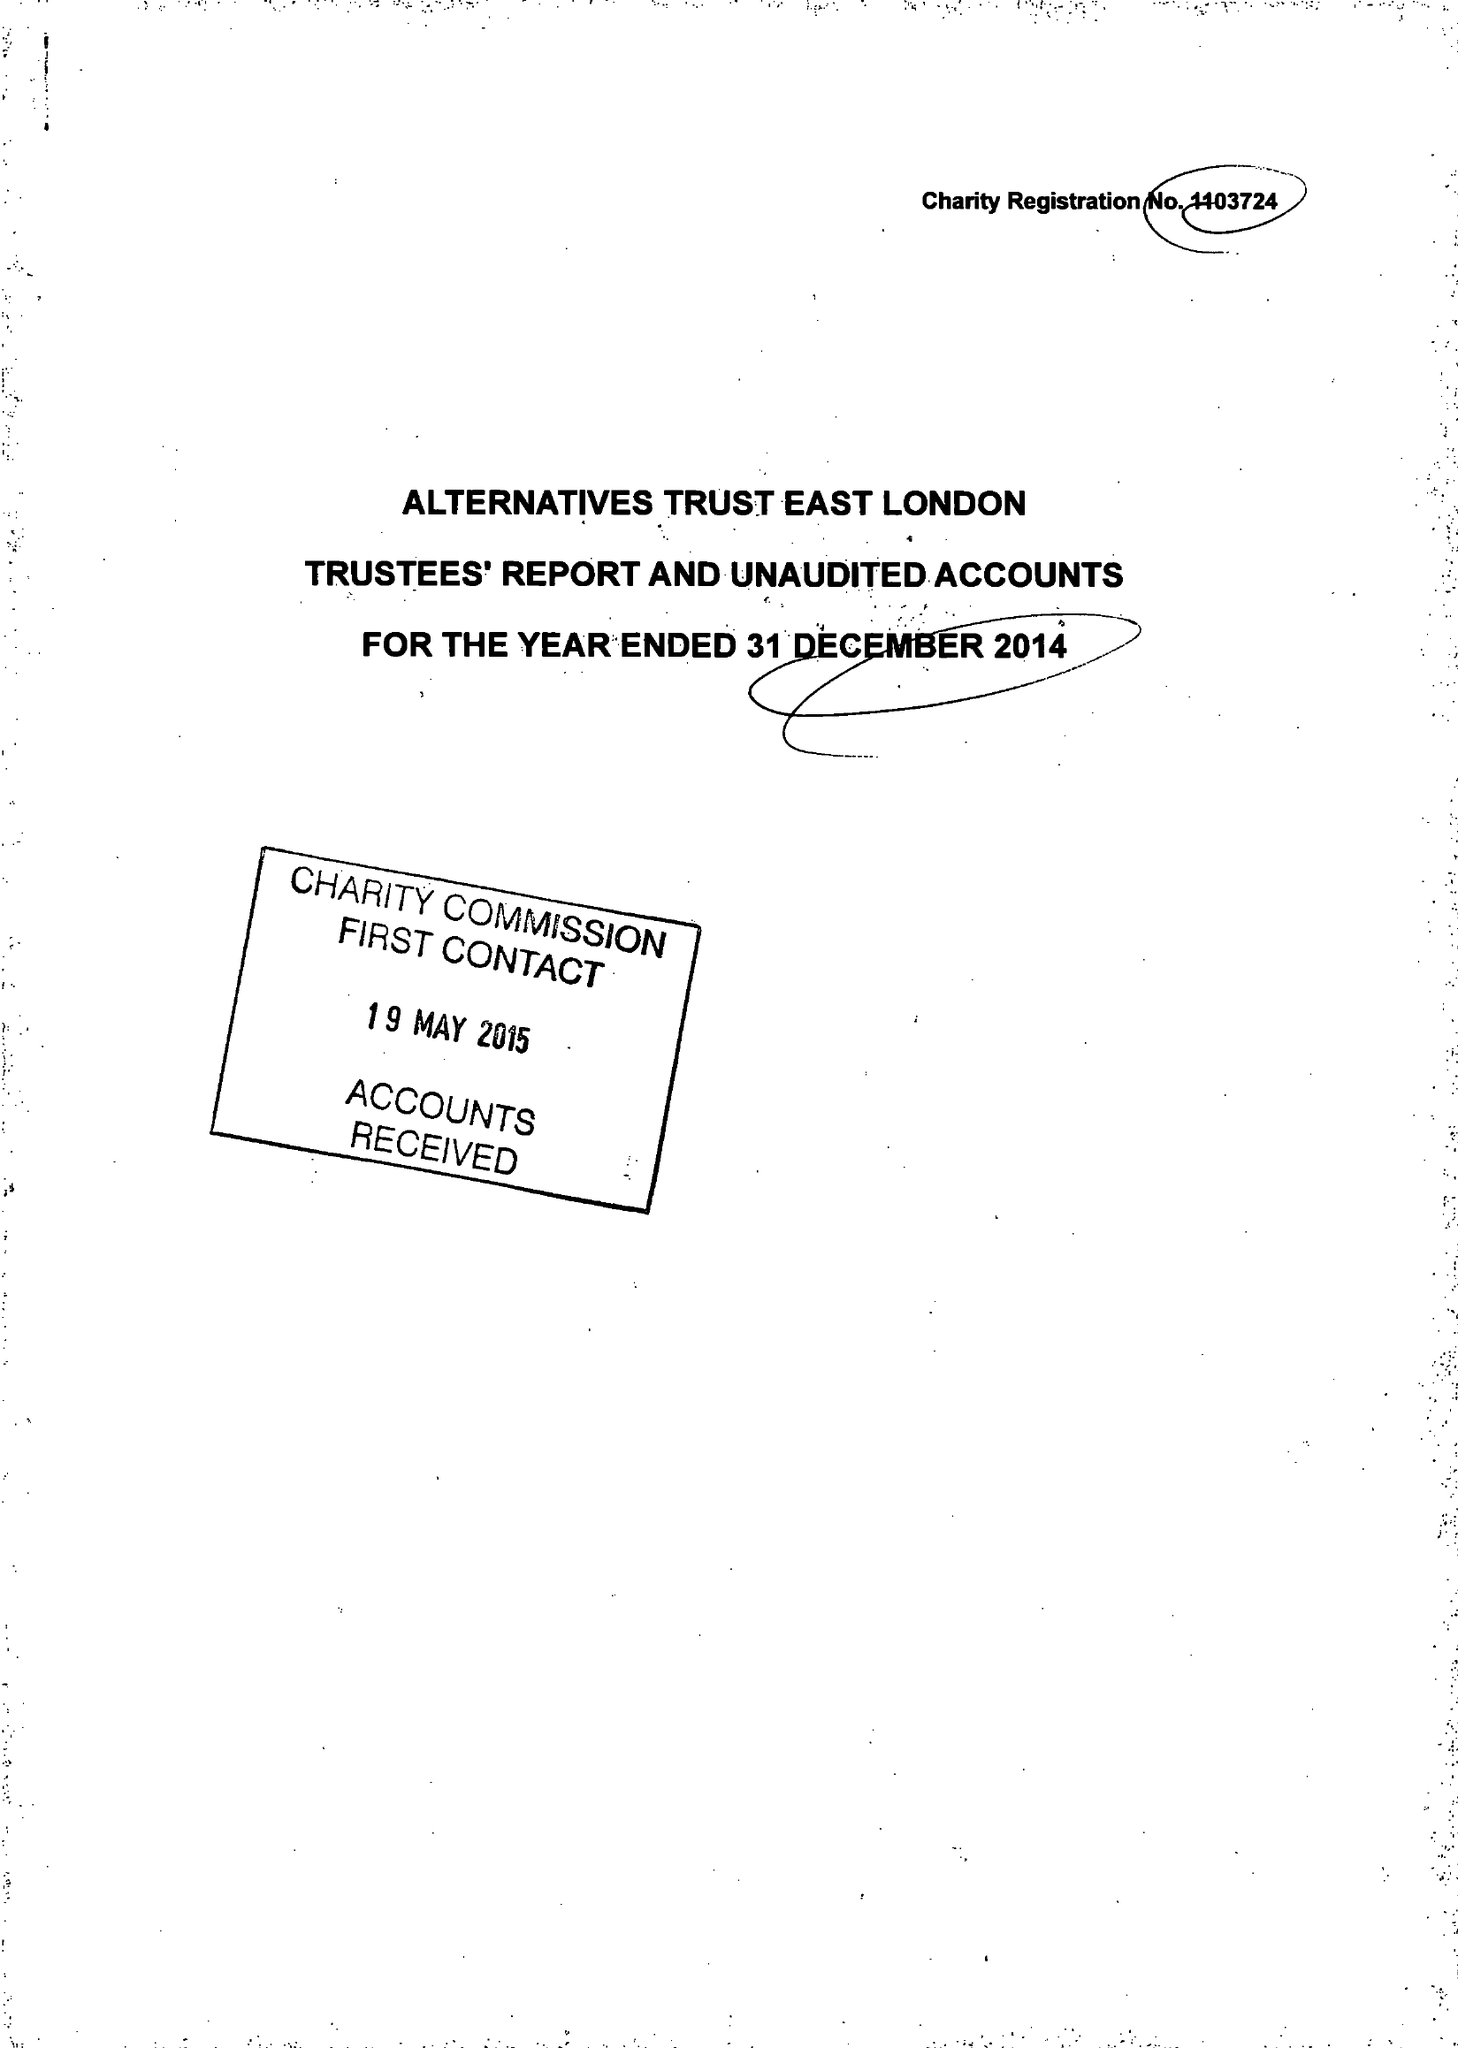What is the value for the address__postcode?
Answer the question using a single word or phrase. E13 8AB 